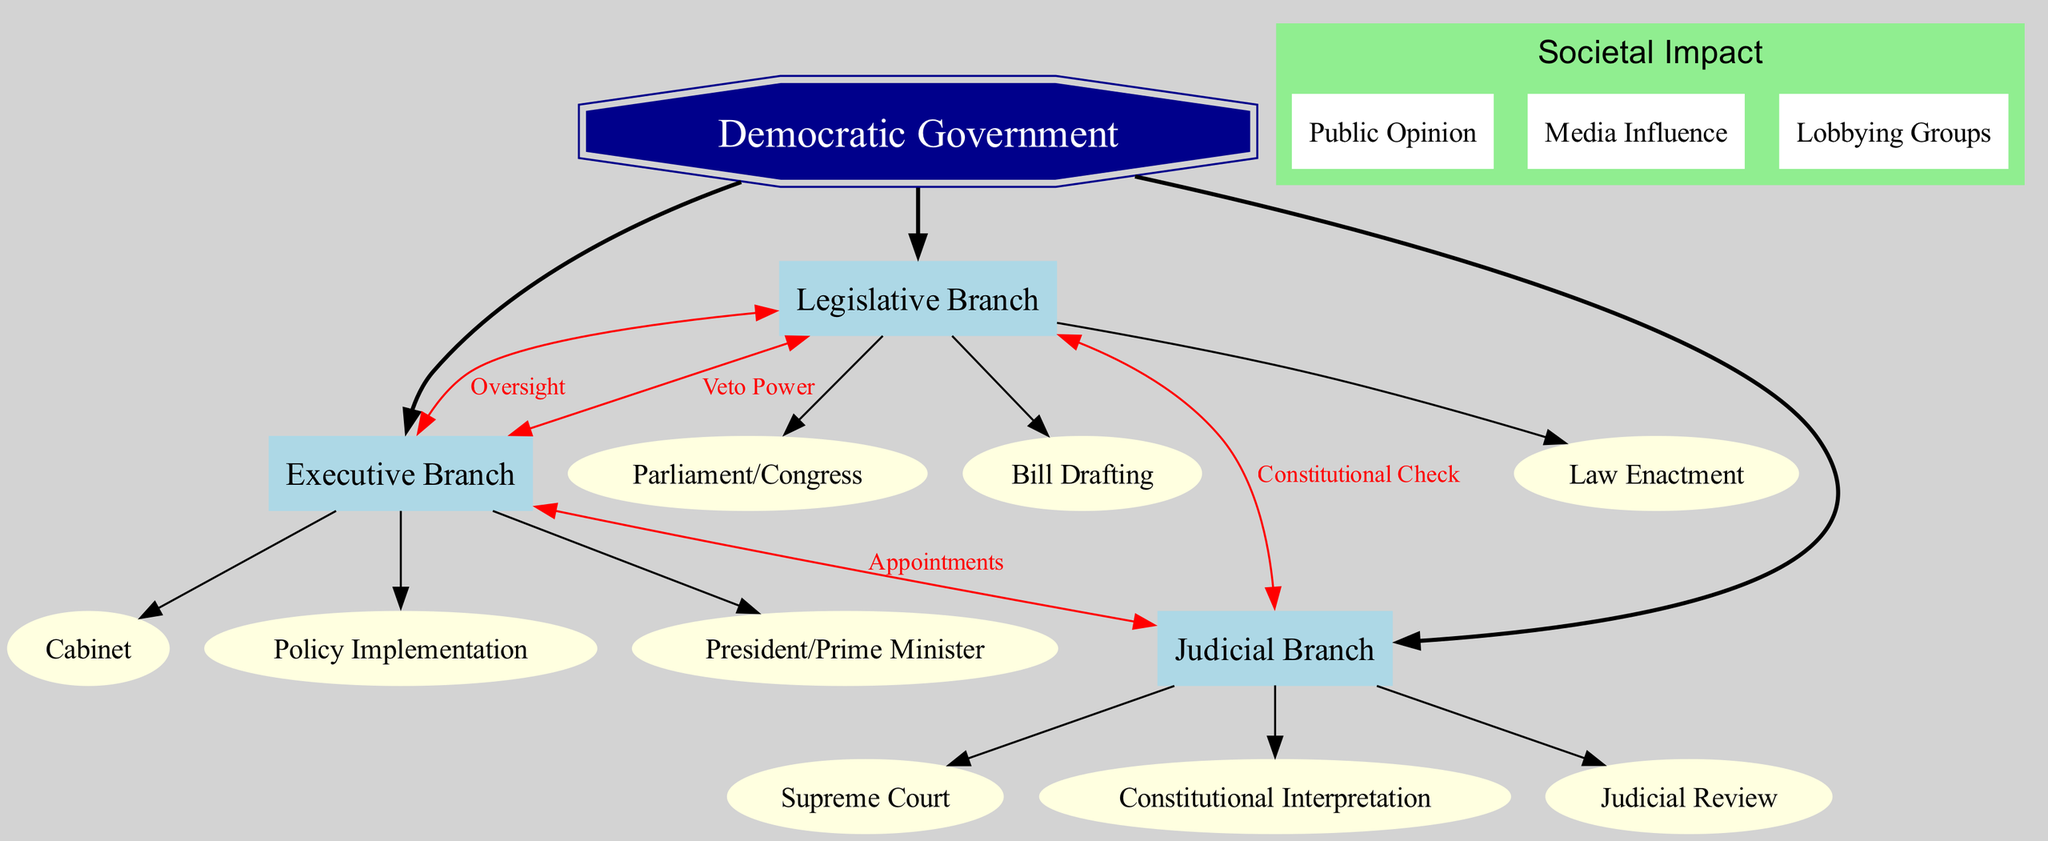What are the main branches of government illustrated in the diagram? The diagram highlights three main branches of government: the Legislative Branch, the Executive Branch, and the Judicial Branch. These branches are explicitly listed within the main sections of the diagram.
Answer: Legislative Branch, Executive Branch, Judicial Branch How many sub-elements are listed under the Executive Branch? The Executive Branch has three sub-elements: President/Prime Minister, Cabinet, and Policy Implementation, which are delineated in the diagram under this branch.
Answer: 3 What is the relationship labeled between the Legislative Branch and the Executive Branch? The relationship labeled between the Legislative Branch and the Executive Branch is "Oversight," clearly indicated by a directed edge connecting these two branches in the diagram.
Answer: Oversight Which branch has the power of veto over the Legislative Branch? The Executive Branch possesses the veto power over the Legislative Branch, as indicated in the diagram by the arrow connecting these two branches labeled "Veto Power."
Answer: Executive Branch What is one societal impact factor indicated in the diagram? The diagram specifies several societal impact factors, one of which is "Public Opinion," clearly listed in the societal impact section of the diagram.
Answer: Public Opinion What type of check does the Judicial Branch provide to the Legislative Branch? The Judicial Branch provides a "Constitutional Check" to the Legislative Branch, as shown in the diagram by the labeled connection from the Judicial Branch to the Legislative Branch.
Answer: Constitutional Check How many interconnections are illustrated between the branches of government? There are four interconnections shown between the branches of government in the diagram, demonstrating how they relate to one another through various labels.
Answer: 4 What is the function of the "Appointments" labeled connection in the diagram? The "Appointments" labeled connection indicates that the Executive Branch has the role of appointing members of the Judicial Branch, as depicted by the directed edge connecting these two branches.
Answer: Appointments 